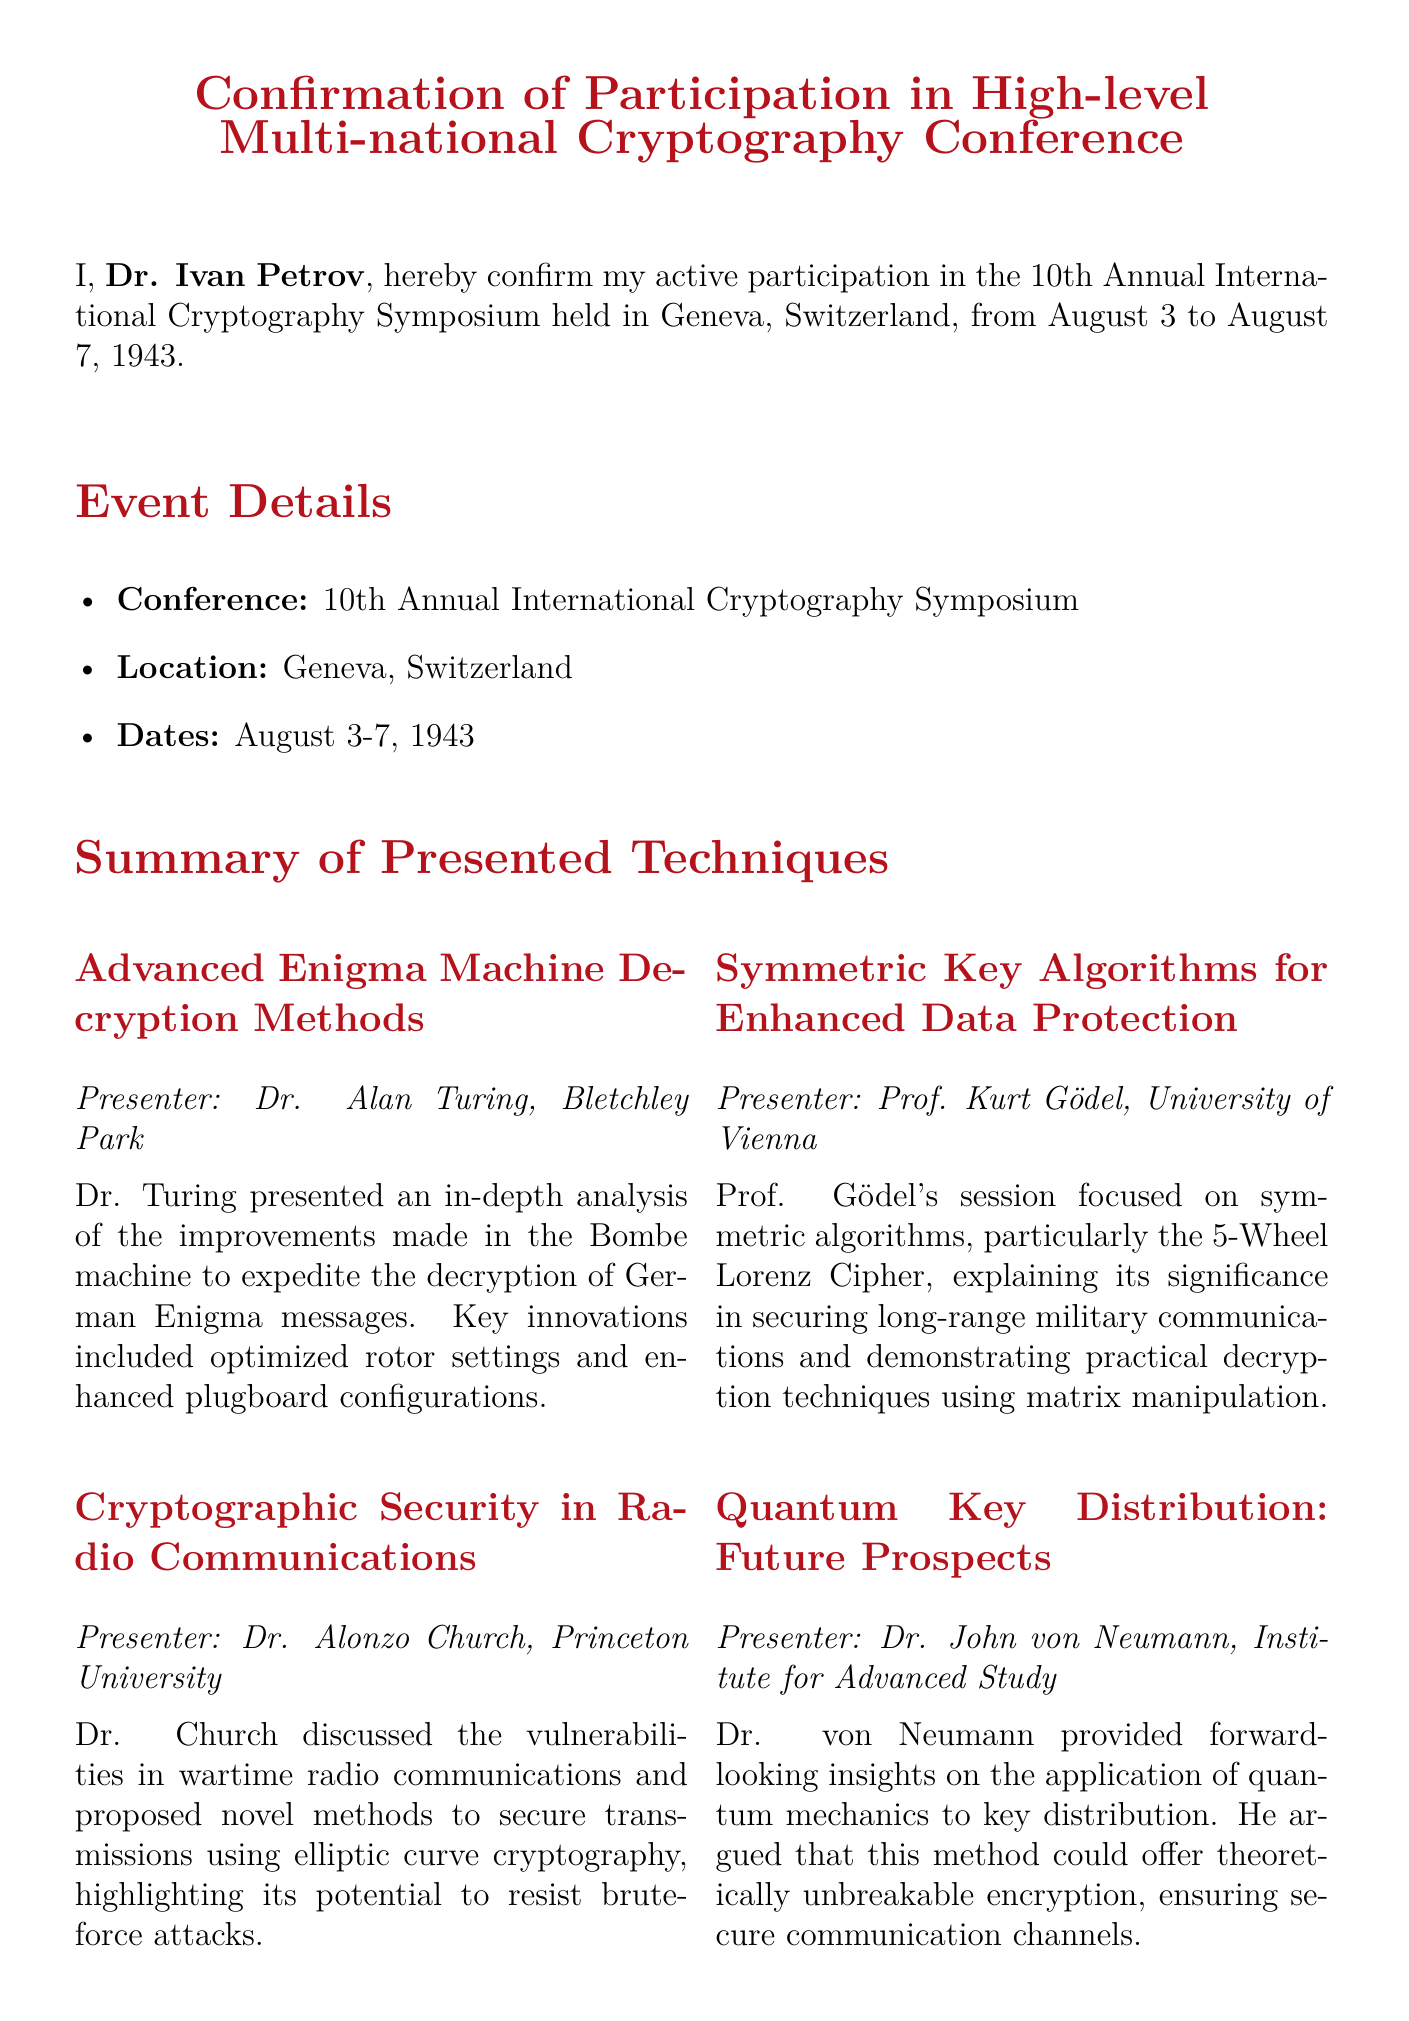What is the name of the conference? The conference is identified in the document as the 10th Annual International Cryptography Symposium.
Answer: 10th Annual International Cryptography Symposium Who presented on the Advanced Enigma Machine Decryption Methods? The document states that Dr. Alan Turing presented on this topic.
Answer: Dr. Alan Turing What are the dates of the conference? The dates of the conference are explicitly mentioned in the document as August 3 to August 7, 1943.
Answer: August 3 to August 7, 1943 What is one of the key discussions mentioned? The document lists several discussions, including ethical implications of cryptanalysis as one of them.
Answer: Ethical Implications of Cryptanalysis Which technique did Prof. Kurt Gödel focus on? The document indicates that Prof. Gödel focused on symmetric key algorithms, specifically the 5-Wheel Lorenz Cipher.
Answer: 5-Wheel Lorenz Cipher What is Dr. John von Neumann's topic about? The document mentions that Dr. von Neumann's topic is Quantum Key Distribution and its future prospects.
Answer: Quantum Key Distribution What is the location of the conference? The conference's location is stated in the document as Geneva, Switzerland.
Answer: Geneva, Switzerland What is the name of the signer of the affidavit? The signer of the affidavit is identified in the document as Dr. Ivan Petrov.
Answer: Dr. Ivan Petrov When was the affidavit signed? The document specifies that the affidavit was signed on August 8, 1943.
Answer: August 8, 1943 